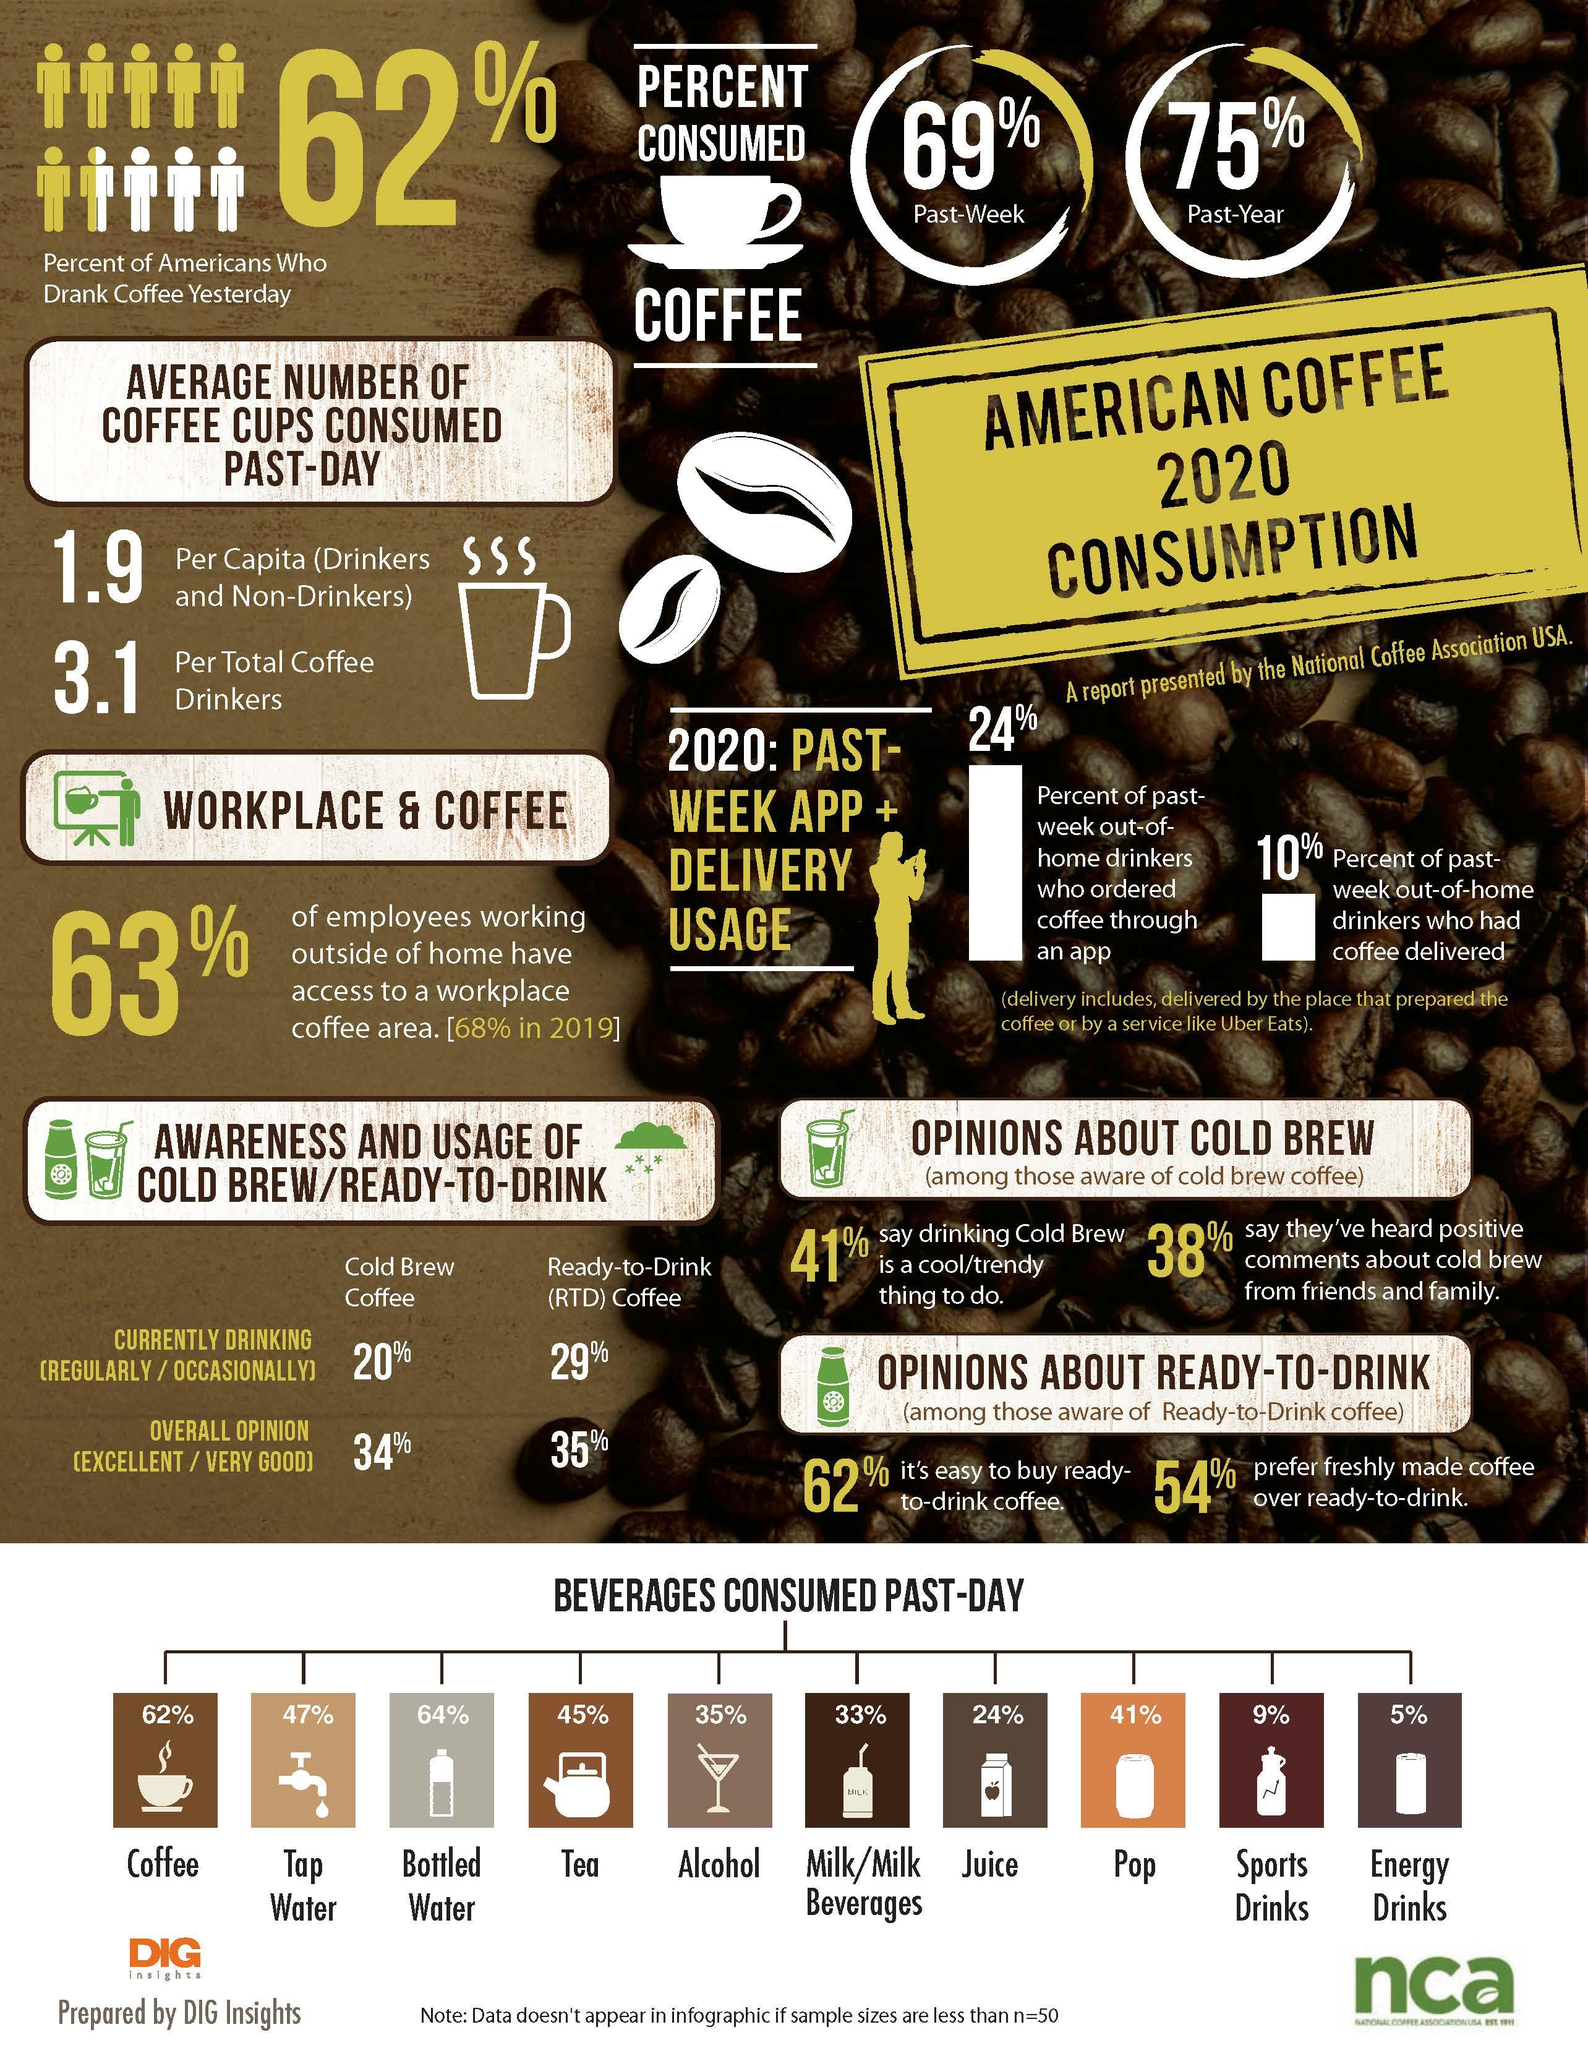Outline some significant characteristics in this image. According to a survey conducted in 2020, approximately 37% of American employees who work outside of their homes do not have access to a workplace coffee area. In 2020, approximately 20% of Americans regularly or occasionally consumed cold coffee brew. In 2020, 35% of alcohol was consumed by Americans in the past day. In 2020, energy drinks were the least consumed beverage by Americans on a daily basis. In 2020, it was reported that coffee was the beverage consumed by the majority of Americans on a daily basis. 